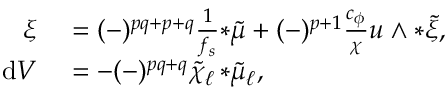Convert formula to latex. <formula><loc_0><loc_0><loc_500><loc_500>\begin{array} { r l } { \xi } & = ( - ) ^ { p q + p + q } \frac { 1 } { f _ { s } } { * \tilde { \mu } } + ( - ) ^ { p + 1 } \frac { c _ { \phi } } { \chi } u \wedge { * \tilde { \xi } } , } \\ { d V } & = - ( - ) ^ { p q + q } \tilde { \chi } _ { \ell } \, { * \tilde { \mu } _ { \ell } } , } \end{array}</formula> 